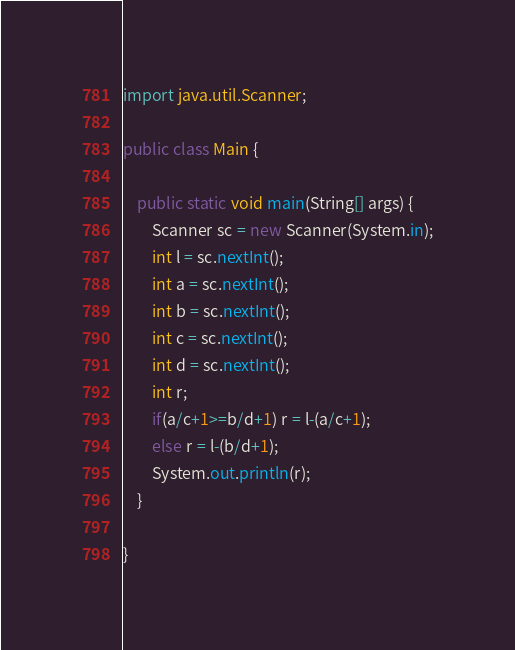Convert code to text. <code><loc_0><loc_0><loc_500><loc_500><_Java_>import java.util.Scanner;

public class Main {

	public static void main(String[] args) {
		Scanner sc = new Scanner(System.in);
		int l = sc.nextInt();
		int a = sc.nextInt();
		int b = sc.nextInt();
		int c = sc.nextInt();
		int d = sc.nextInt();
		int r;
		if(a/c+1>=b/d+1) r = l-(a/c+1);
		else r = l-(b/d+1);
		System.out.println(r);
	}

}</code> 